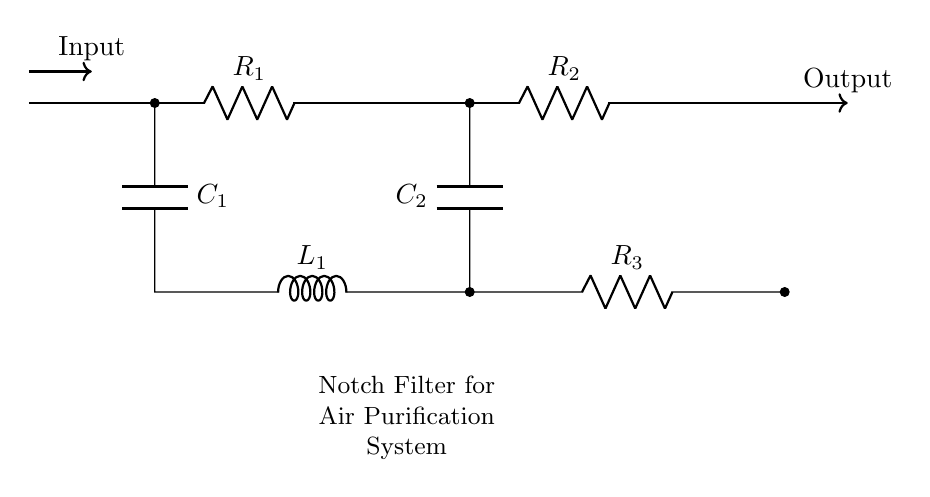What is the total number of resistors in the circuit? There are three resistors labeled R1, R2, and R3 in the circuit diagram. By counting the labeled components, we find that the total is three.
Answer: three What is the value of the components connected in parallel? In the circuit, C1 and C2 are connected in a parallel arrangement with L1 between them. In parallel, the voltage across these components remains the same. The reactance of L1 and the capacitors C1 and C2 determines the frequency at which the notch filter operates.
Answer: C1 and C2 in parallel What is the purpose of this notch filter? A notch filter is used to eliminate specific frequencies of interference from signals, which is critical in air purification systems to minimize noise and improve air quality. By selectively attenuating certain frequencies, it enhances system performance.
Answer: eliminate interference What type of circuit is represented? The circuit is represented as a notch filter designed specifically for air purification systems, characterized by its arrangement of resistors, capacitors, and inductors to filter out unwanted interference.
Answer: notch filter Which component provides inductance in the circuit? The component that provides inductance is labeled L1. It reacts to current changes within the circuit and is essential in defining the notch filter’s frequency response.
Answer: L1 What is the input signal configuration for this circuit? The input signal is fed into the circuit from the left side, as indicated by the arrow labeled 'Input', which indicates the direction of the signal flow into the filter.
Answer: Input 